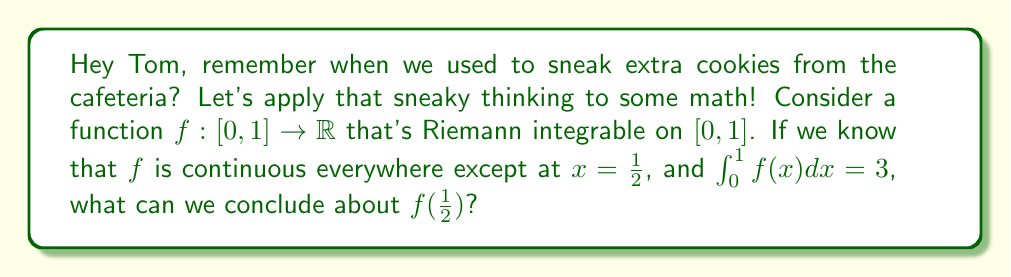Can you answer this question? Alright, buddy, let's break this down step by step:

1) First, recall the properties of Riemann integrable functions on a closed interval:
   - A function is Riemann integrable if and only if it's bounded and continuous almost everywhere.
   - The set of discontinuities of a Riemann integrable function has measure zero.

2) In our case, $f$ is continuous everywhere except at $x=\frac{1}{2}$. This single point of discontinuity doesn't affect the Riemann integrability of $f$ on $[0,1]$.

3) Now, let's consider a key theorem about Riemann integrable functions:
   - If $f$ is Riemann integrable on $[a,b]$ and has only a finite number of discontinuities, then:
     $$\int_a^b f(x)dx = \int_a^b \bar{f}(x)dx$$
   where $\bar{f}$ is the function that agrees with $f$ at all points of continuity and takes the average of the left and right limits at points of discontinuity.

4) In our case, this means:
   $$\int_0^1 f(x)dx = \int_0^1 \bar{f}(x)dx = 3$$

5) Moreover, $\bar{f}(\frac{1}{2}) = \frac{1}{2}[f(\frac{1}{2}^-) + f(\frac{1}{2}^+)]$, where $f(\frac{1}{2}^-)$ and $f(\frac{1}{2}^+)$ are the left and right limits of $f$ at $\frac{1}{2}$, respectively.

6) Since $f$ is continuous everywhere except at $\frac{1}{2}$, these limits exist and are equal to the function values approaching $\frac{1}{2}$ from left and right.

7) The value of $f$ at $\frac{1}{2}$ doesn't affect the integral, as it's just a single point. The integral depends on the limits $f(\frac{1}{2}^-)$ and $f(\frac{1}{2}^+)$, not on $f(\frac{1}{2})$ itself.

Therefore, we can't determine the exact value of $f(\frac{1}{2})$ from the given information. The function could take any value at $x=\frac{1}{2}$ without changing its Riemann integrability or the value of the integral.
Answer: The value of $f(\frac{1}{2})$ cannot be determined from the given information. It can be any real number without affecting the Riemann integrability of $f$ on $[0,1]$ or the value of $\int_0^1 f(x)dx$. 